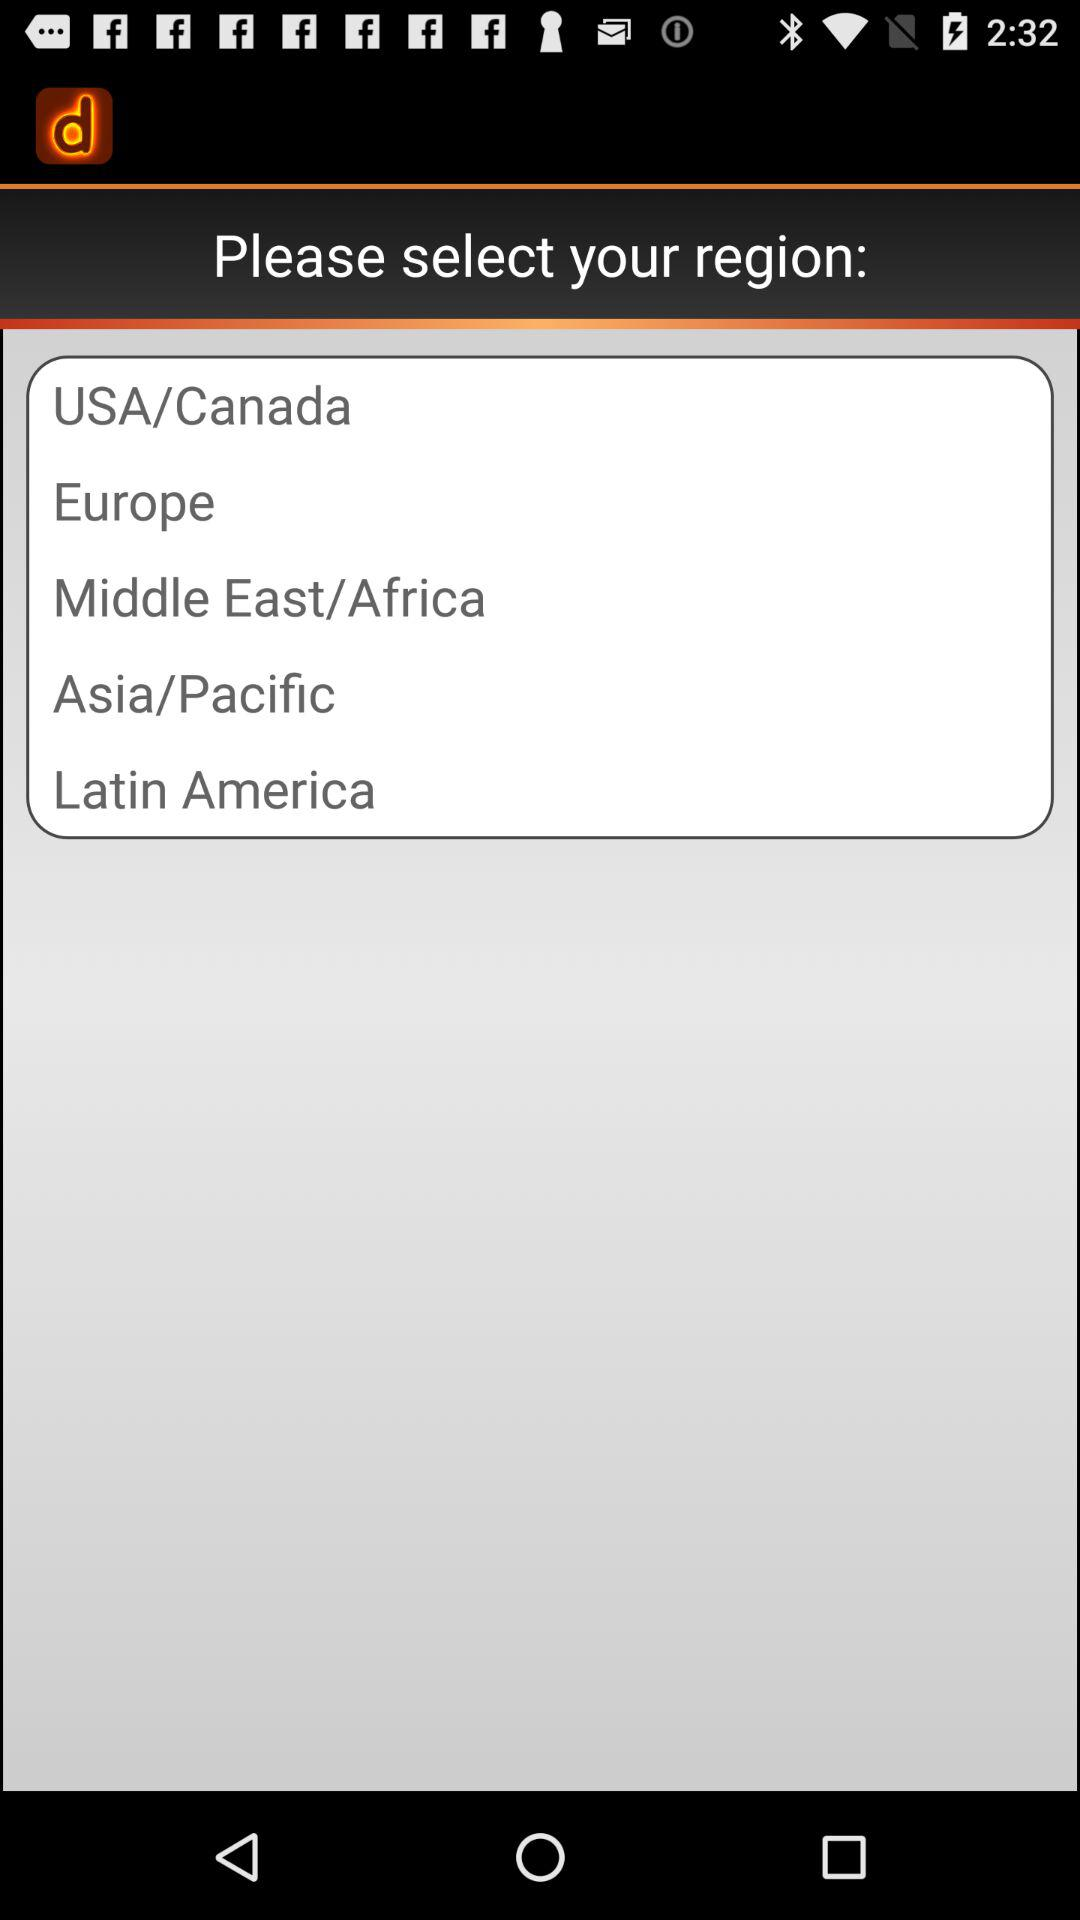How many regions are there in total?
Answer the question using a single word or phrase. 5 